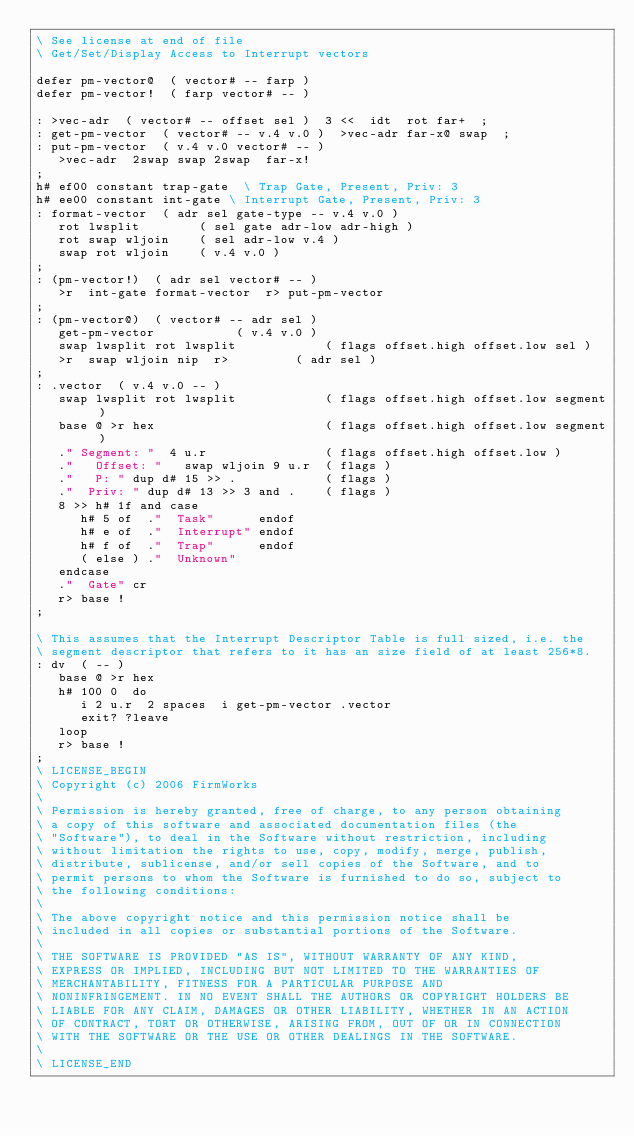Convert code to text. <code><loc_0><loc_0><loc_500><loc_500><_Forth_>\ See license at end of file
\ Get/Set/Display Access to Interrupt vectors

defer pm-vector@  ( vector# -- farp )
defer pm-vector!  ( farp vector# -- )

: >vec-adr  ( vector# -- offset sel )  3 <<  idt  rot far+  ;
: get-pm-vector  ( vector# -- v.4 v.0 )  >vec-adr far-x@ swap  ;
: put-pm-vector  ( v.4 v.0 vector# -- )
   >vec-adr  2swap swap 2swap  far-x!
;
h# ef00 constant trap-gate	\ Trap Gate, Present, Priv: 3
h# ee00 constant int-gate	\ Interrupt Gate, Present, Priv: 3
: format-vector  ( adr sel gate-type -- v.4 v.0 )
   rot lwsplit        ( sel gate adr-low adr-high )
   rot swap wljoin    ( sel adr-low v.4 )
   swap rot wljoin    ( v.4 v.0 )
;
: (pm-vector!)  ( adr sel vector# -- )
   >r  int-gate format-vector  r> put-pm-vector
;
: (pm-vector@)  ( vector# -- adr sel )
   get-pm-vector		       ( v.4 v.0 )
   swap lwsplit rot lwsplit            ( flags offset.high offset.low sel )
   >r  swap wljoin nip  r>	       ( adr sel )
;
: .vector  ( v.4 v.0 -- )
   swap lwsplit rot lwsplit            ( flags offset.high offset.low segment )
   base @ >r hex                       ( flags offset.high offset.low segment )
   ." Segment: "  4 u.r                ( flags offset.high offset.low )
   ."   Offset: "   swap wljoin 9 u.r  ( flags ) 
   ."   P: " dup d# 15 >> .            ( flags )
   ."  Priv: " dup d# 13 >> 3 and .    ( flags )
   8 >> h# 1f and case
      h# 5 of  ."  Task"      endof
      h# e of  ."  Interrupt" endof
      h# f of  ."  Trap"      endof
      ( else ) ."  Unknown"
   endcase
   ."  Gate" cr
   r> base !
;

\ This assumes that the Interrupt Descriptor Table is full sized, i.e. the
\ segment descriptor that refers to it has an size field of at least 256*8.
: dv  ( -- )
   base @ >r hex
   h# 100 0  do
      i 2 u.r  2 spaces  i get-pm-vector .vector
      exit? ?leave
   loop
   r> base !
;
\ LICENSE_BEGIN
\ Copyright (c) 2006 FirmWorks
\ 
\ Permission is hereby granted, free of charge, to any person obtaining
\ a copy of this software and associated documentation files (the
\ "Software"), to deal in the Software without restriction, including
\ without limitation the rights to use, copy, modify, merge, publish,
\ distribute, sublicense, and/or sell copies of the Software, and to
\ permit persons to whom the Software is furnished to do so, subject to
\ the following conditions:
\ 
\ The above copyright notice and this permission notice shall be
\ included in all copies or substantial portions of the Software.
\ 
\ THE SOFTWARE IS PROVIDED "AS IS", WITHOUT WARRANTY OF ANY KIND,
\ EXPRESS OR IMPLIED, INCLUDING BUT NOT LIMITED TO THE WARRANTIES OF
\ MERCHANTABILITY, FITNESS FOR A PARTICULAR PURPOSE AND
\ NONINFRINGEMENT. IN NO EVENT SHALL THE AUTHORS OR COPYRIGHT HOLDERS BE
\ LIABLE FOR ANY CLAIM, DAMAGES OR OTHER LIABILITY, WHETHER IN AN ACTION
\ OF CONTRACT, TORT OR OTHERWISE, ARISING FROM, OUT OF OR IN CONNECTION
\ WITH THE SOFTWARE OR THE USE OR OTHER DEALINGS IN THE SOFTWARE.
\
\ LICENSE_END
</code> 